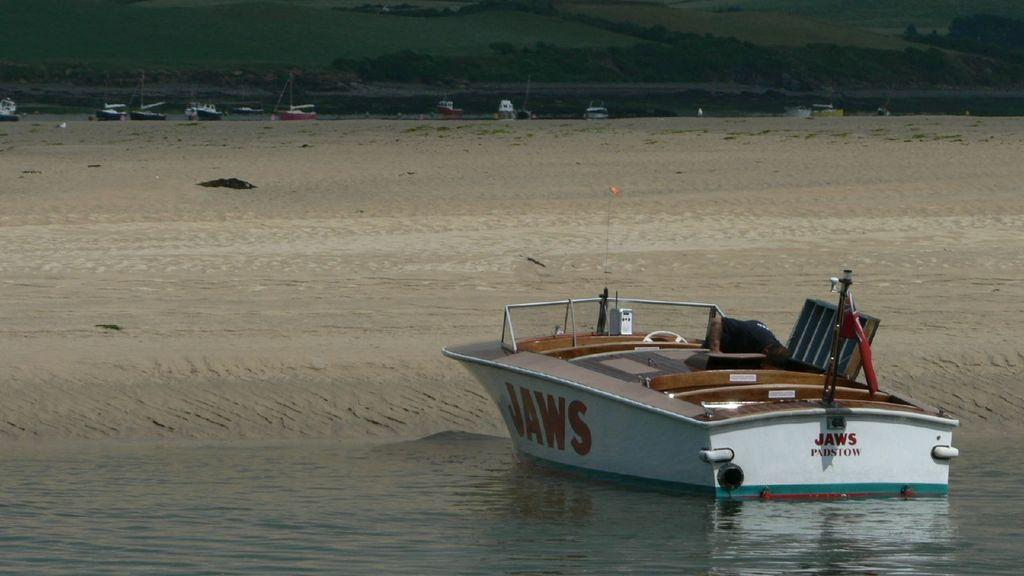What is the main subject of the image? There is a boat in the image. Where is the boat located? The boat is on the water. What can be seen on the boat? There is text on the walls of the boat. What is visible behind the boat? There is sand on the ground behind the boat. What can be seen in the distance in the image? There are boats visible in the background of the image, and there are hills in the background as well. How does the boat express anger in the image? The boat does not express anger in the image, as boats do not have emotions. 